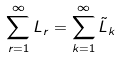<formula> <loc_0><loc_0><loc_500><loc_500>\sum _ { r = 1 } ^ { \infty } L _ { r } = \sum _ { k = 1 } ^ { \infty } \tilde { L } _ { k }</formula> 